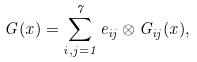Convert formula to latex. <formula><loc_0><loc_0><loc_500><loc_500>G ( x ) = \sum _ { i , j = 1 } ^ { 7 } e _ { i j } \otimes G _ { i j } ( x ) ,</formula> 